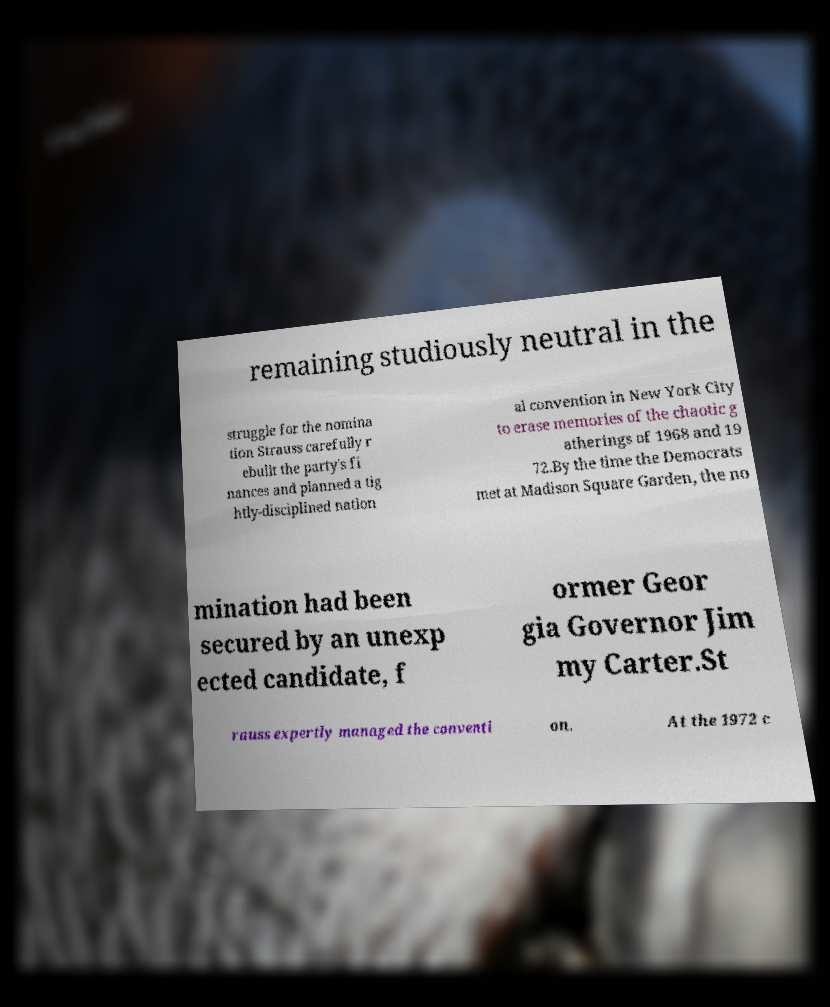For documentation purposes, I need the text within this image transcribed. Could you provide that? remaining studiously neutral in the struggle for the nomina tion Strauss carefully r ebuilt the party's fi nances and planned a tig htly-disciplined nation al convention in New York City to erase memories of the chaotic g atherings of 1968 and 19 72.By the time the Democrats met at Madison Square Garden, the no mination had been secured by an unexp ected candidate, f ormer Geor gia Governor Jim my Carter.St rauss expertly managed the conventi on. At the 1972 c 